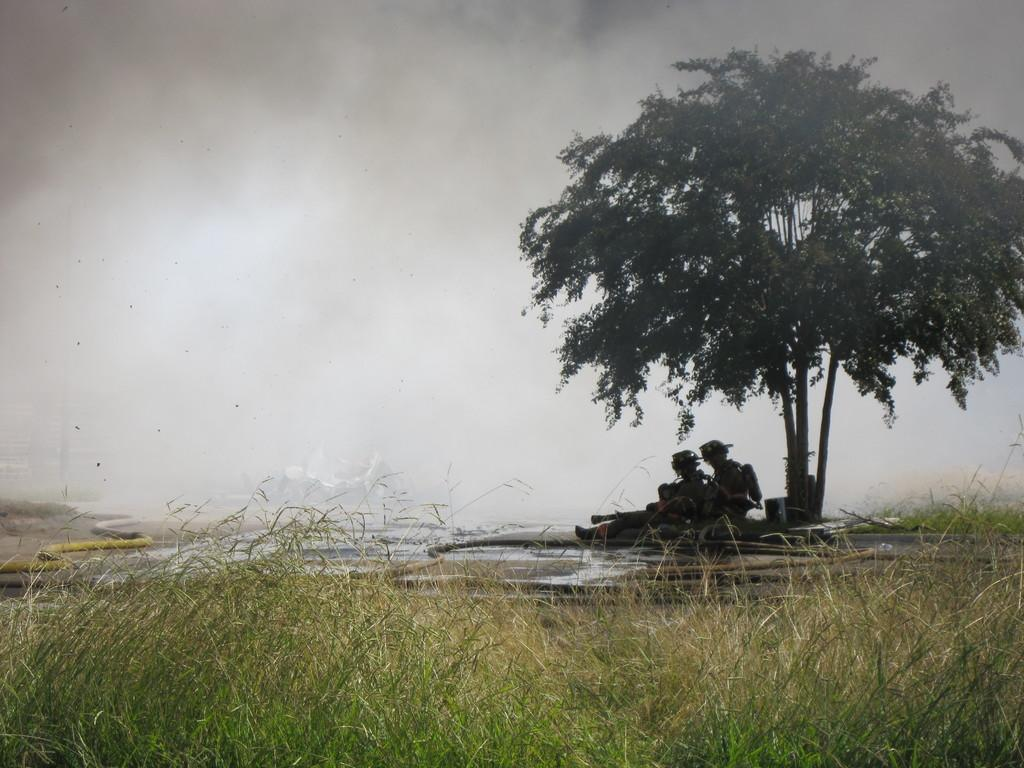How many people are in the image? There are two persons in the image. Where are the persons located in the image? The persons are under a tree. What objects are beside the persons? There are pipes beside the persons. What can be seen behind the persons? There is smoke visible behind the persons. What type of ground is present at the bottom of the image? Grass is present at the bottom of the image. What type of tail can be seen on the persons in the image? There are no tails visible on the persons in the image. What kind of structure is present behind the persons? There is no structure present behind the persons; only smoke is visible. 